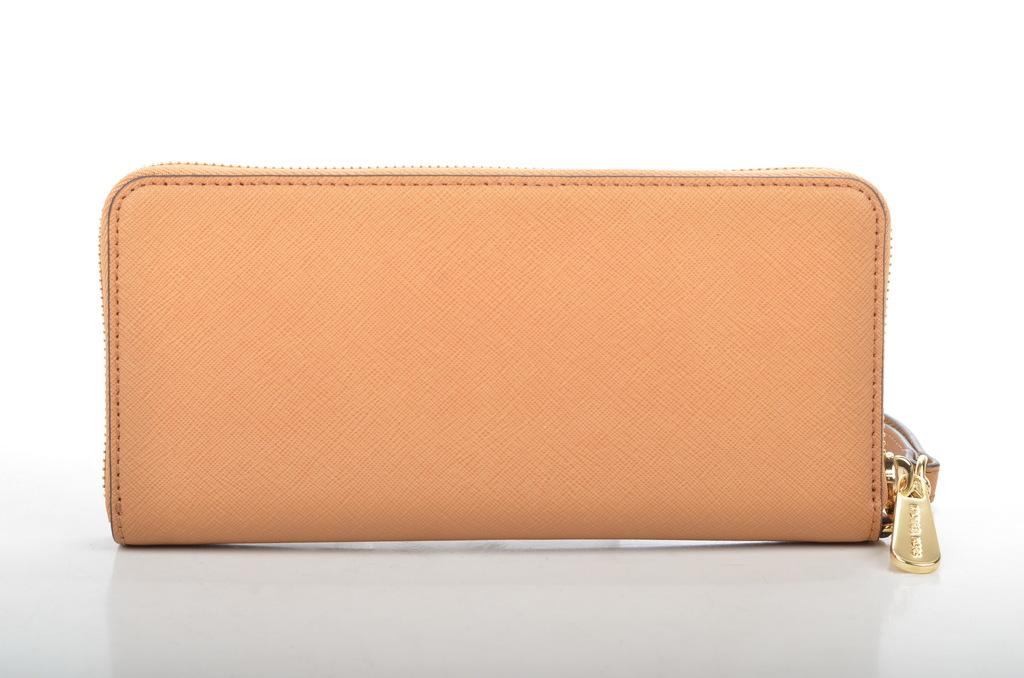What color is the purse in the image? The purse in the image is orange. What is the purse placed on in the image? The purse is placed on a white platform. What time does the clock on the purse show in the image? There is no clock present on the purse in the image. 